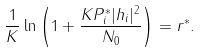Convert formula to latex. <formula><loc_0><loc_0><loc_500><loc_500>\frac { 1 } { K } \ln \left ( 1 + \frac { K P _ { i } ^ { * } | h _ { i } | ^ { 2 } } { N _ { 0 } } \right ) = r ^ { * } .</formula> 